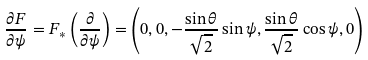<formula> <loc_0><loc_0><loc_500><loc_500>\frac { \partial F } { \partial \psi } = F _ { \ast } \left ( \frac { \partial } { \partial \psi } \right ) = \left ( 0 , 0 , - \frac { \sin \theta } { \sqrt { 2 } } \sin \psi , \frac { \sin \theta } { \sqrt { 2 } } \cos \psi , 0 \right )</formula> 